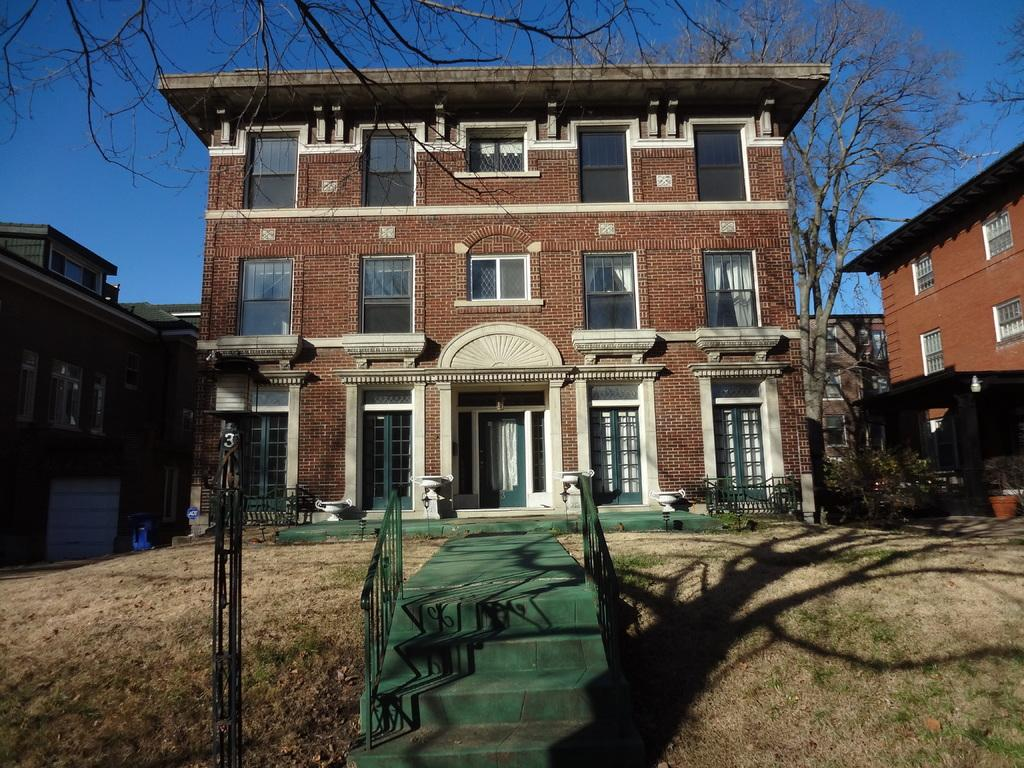What type of structure is present in the image? The image contains a building. What features can be observed on the building? The building has doors and windows. What architectural element is present at the bottom of the building? There are stairs at the bottom of the building. What can be seen at the top of the image? There are trees and the sky visible at the top of the image. What color is the ink spilled on the building in the image? There is no ink spilled on the building in the image. How many stars can be seen on the building in the image? There are no stars depicted on the building in the image. 